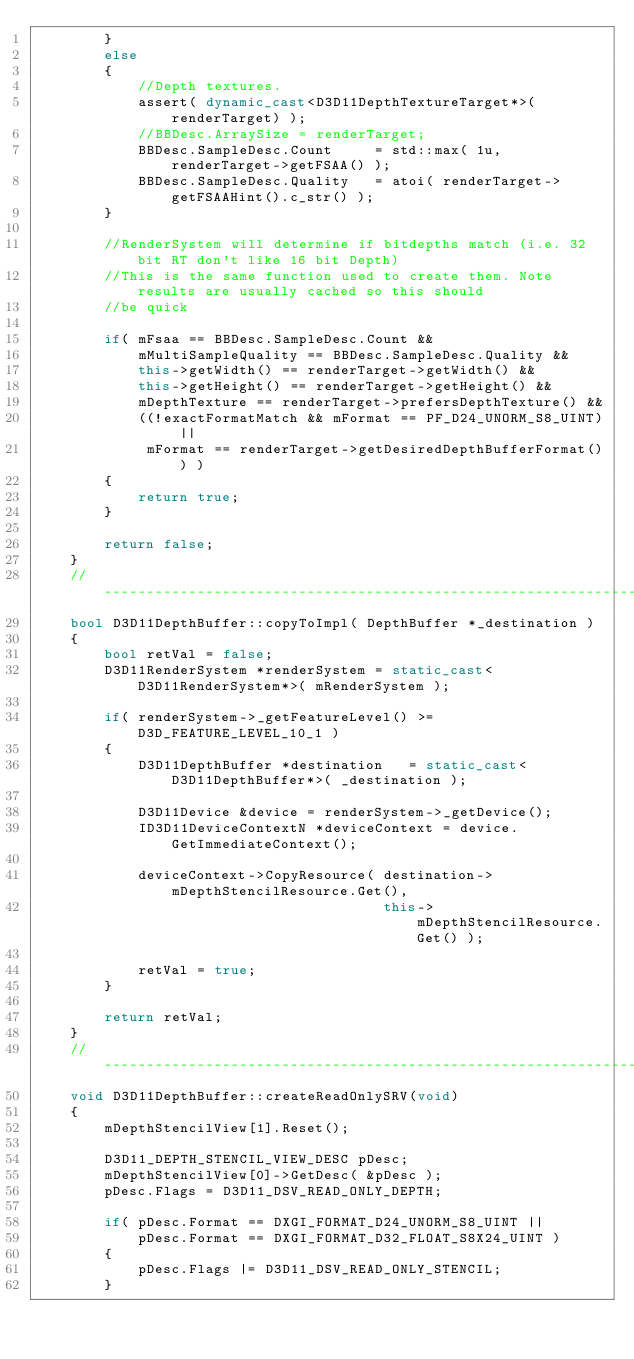<code> <loc_0><loc_0><loc_500><loc_500><_C++_>        }
        else
        {
            //Depth textures.
            assert( dynamic_cast<D3D11DepthTextureTarget*>(renderTarget) );
            //BBDesc.ArraySize = renderTarget;
            BBDesc.SampleDesc.Count     = std::max( 1u, renderTarget->getFSAA() );
            BBDesc.SampleDesc.Quality   = atoi( renderTarget->getFSAAHint().c_str() );
        }

        //RenderSystem will determine if bitdepths match (i.e. 32 bit RT don't like 16 bit Depth)
        //This is the same function used to create them. Note results are usually cached so this should
        //be quick

        if( mFsaa == BBDesc.SampleDesc.Count &&
            mMultiSampleQuality == BBDesc.SampleDesc.Quality &&
            this->getWidth() == renderTarget->getWidth() &&
            this->getHeight() == renderTarget->getHeight() &&
            mDepthTexture == renderTarget->prefersDepthTexture() &&
            ((!exactFormatMatch && mFormat == PF_D24_UNORM_S8_UINT) ||
             mFormat == renderTarget->getDesiredDepthBufferFormat()) )
        {
            return true;
        }

        return false;
    }
    //---------------------------------------------------------------------
    bool D3D11DepthBuffer::copyToImpl( DepthBuffer *_destination )
    {
        bool retVal = false;
        D3D11RenderSystem *renderSystem = static_cast<D3D11RenderSystem*>( mRenderSystem );

        if( renderSystem->_getFeatureLevel() >= D3D_FEATURE_LEVEL_10_1 )
        {
            D3D11DepthBuffer *destination   = static_cast<D3D11DepthBuffer*>( _destination );

            D3D11Device &device = renderSystem->_getDevice();
            ID3D11DeviceContextN *deviceContext = device.GetImmediateContext();

            deviceContext->CopyResource( destination->mDepthStencilResource.Get(),
                                         this->mDepthStencilResource.Get() );

            retVal = true;
        }

        return retVal;
    }
    //---------------------------------------------------------------------
    void D3D11DepthBuffer::createReadOnlySRV(void)
    {
        mDepthStencilView[1].Reset();

        D3D11_DEPTH_STENCIL_VIEW_DESC pDesc;
        mDepthStencilView[0]->GetDesc( &pDesc );
        pDesc.Flags = D3D11_DSV_READ_ONLY_DEPTH;

        if( pDesc.Format == DXGI_FORMAT_D24_UNORM_S8_UINT ||
            pDesc.Format == DXGI_FORMAT_D32_FLOAT_S8X24_UINT )
        {
            pDesc.Flags |= D3D11_DSV_READ_ONLY_STENCIL;
        }
</code> 